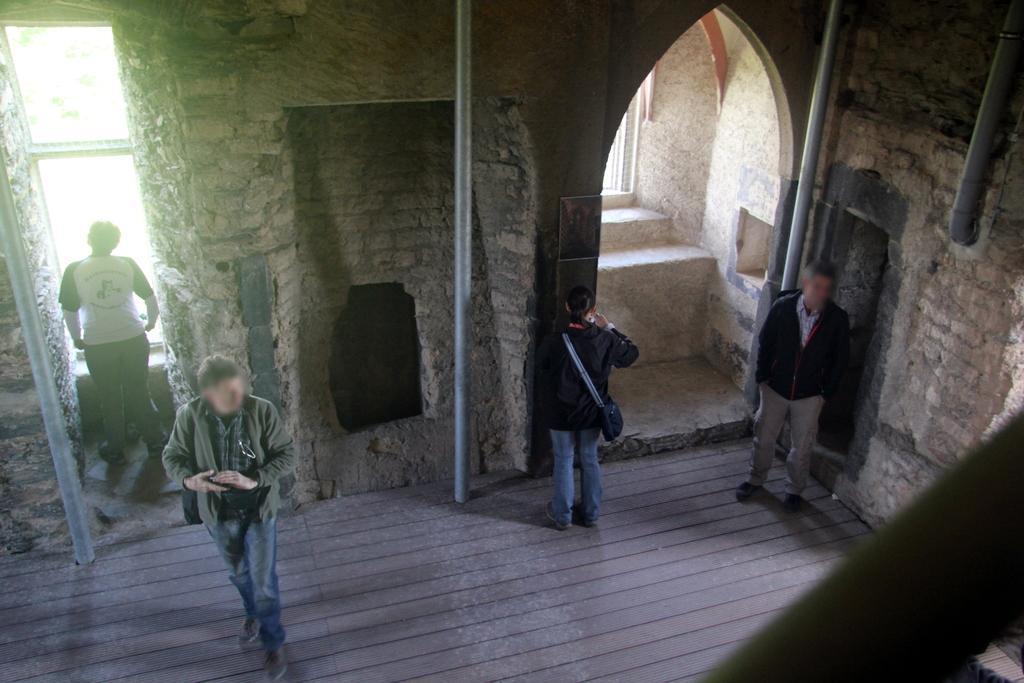Please provide a concise description of this image. This is an inside view. Here I can see four people are standing. In this room I can see three poles. These people are wearing bags to their hands. 